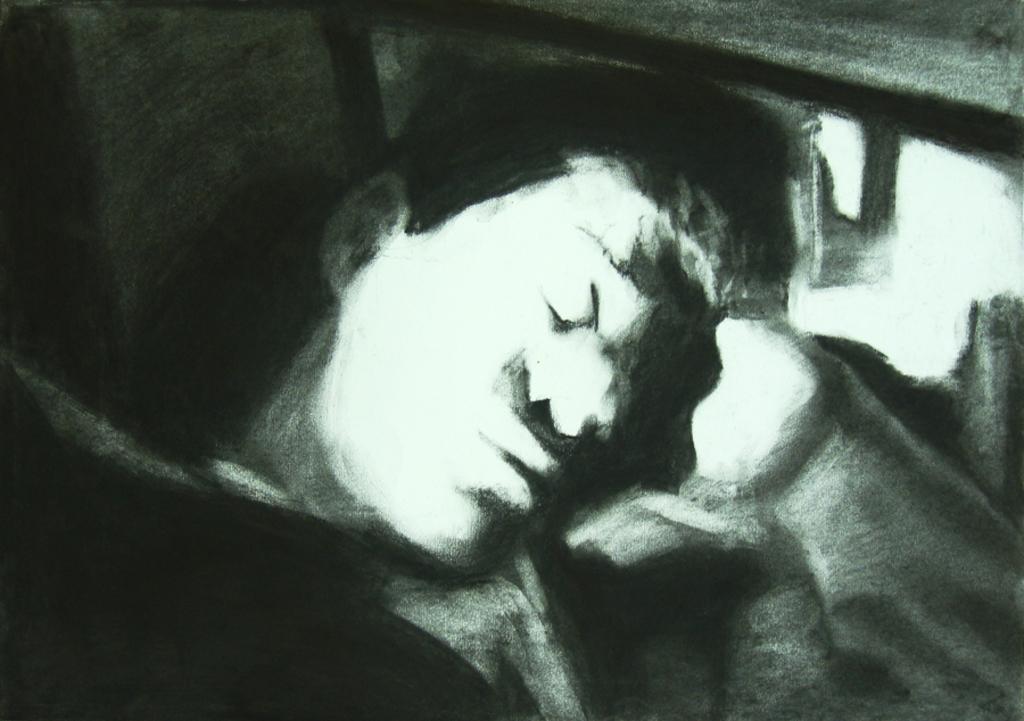In one or two sentences, can you explain what this image depicts? In this picture there is a portrait of a man in the image. 